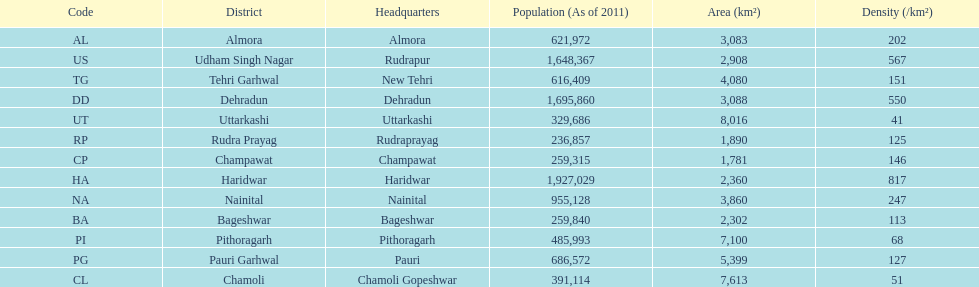Which code is above cl BA. 